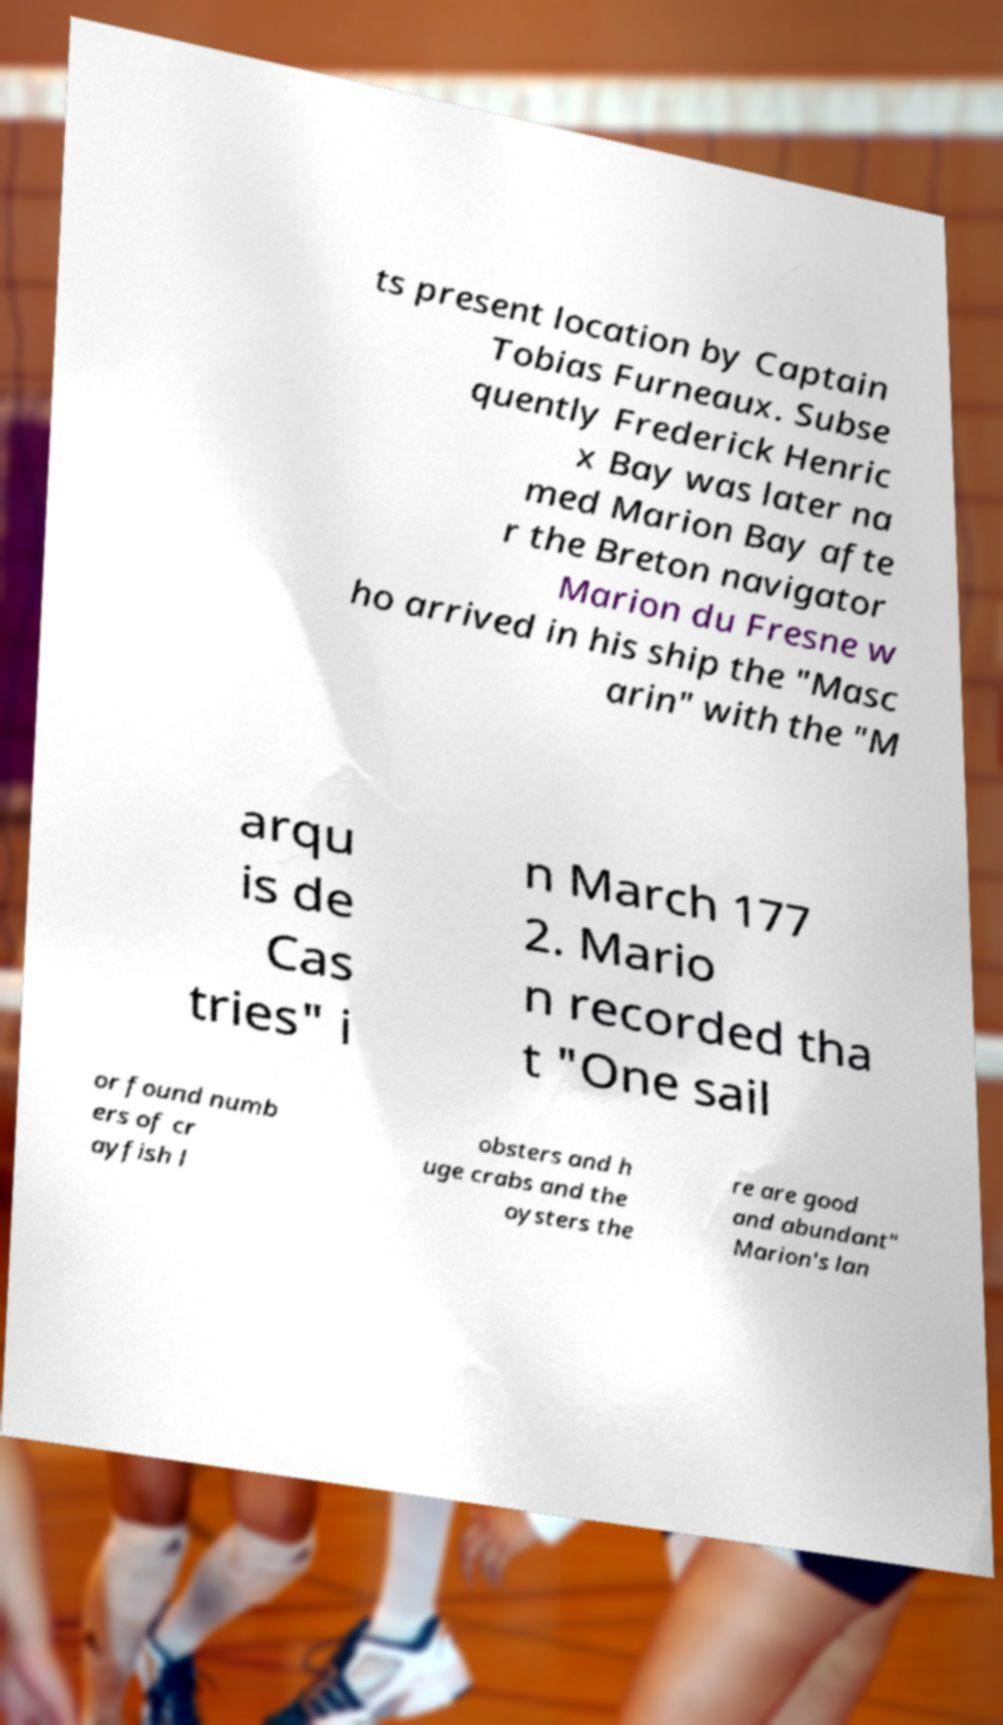For documentation purposes, I need the text within this image transcribed. Could you provide that? ts present location by Captain Tobias Furneaux. Subse quently Frederick Henric x Bay was later na med Marion Bay afte r the Breton navigator Marion du Fresne w ho arrived in his ship the "Masc arin" with the "M arqu is de Cas tries" i n March 177 2. Mario n recorded tha t "One sail or found numb ers of cr ayfish l obsters and h uge crabs and the oysters the re are good and abundant" Marion's lan 